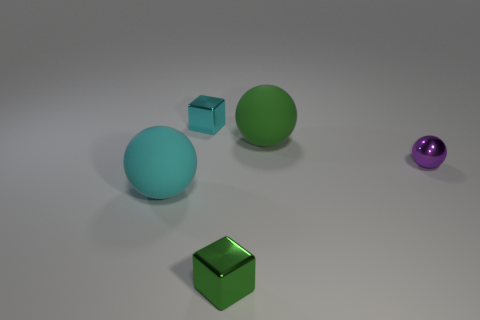Add 5 large shiny objects. How many objects exist? 10 Subtract all big spheres. How many spheres are left? 1 Subtract all cubes. How many objects are left? 3 Subtract 2 spheres. How many spheres are left? 1 Subtract all cyan cubes. How many cubes are left? 1 Subtract all brown blocks. Subtract all green spheres. How many blocks are left? 2 Subtract all matte balls. Subtract all shiny spheres. How many objects are left? 2 Add 1 green metal blocks. How many green metal blocks are left? 2 Add 5 small balls. How many small balls exist? 6 Subtract 1 purple balls. How many objects are left? 4 